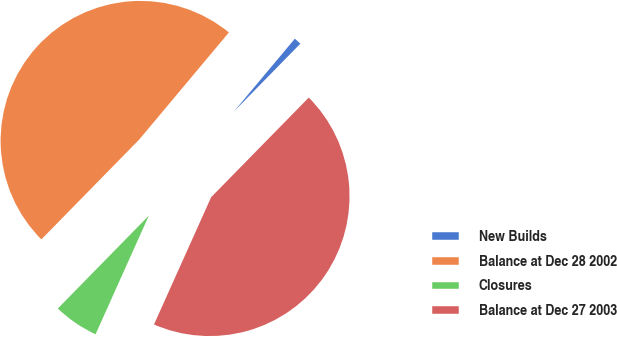Convert chart. <chart><loc_0><loc_0><loc_500><loc_500><pie_chart><fcel>New Builds<fcel>Balance at Dec 28 2002<fcel>Closures<fcel>Balance at Dec 27 2003<nl><fcel>1.24%<fcel>48.76%<fcel>5.62%<fcel>44.38%<nl></chart> 